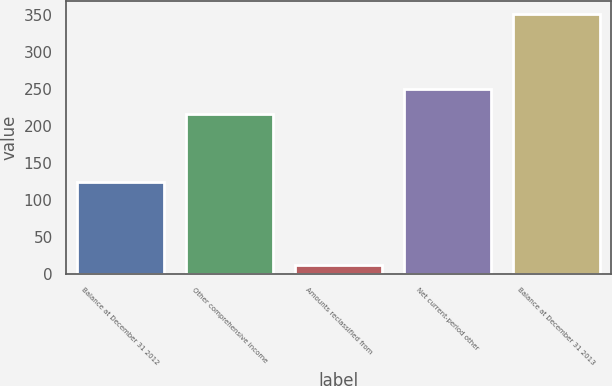<chart> <loc_0><loc_0><loc_500><loc_500><bar_chart><fcel>Balance at December 31 2012<fcel>Other comprehensive income<fcel>Amounts reclassified from<fcel>Net current-period other<fcel>Balance at December 31 2013<nl><fcel>124<fcel>216<fcel>12<fcel>250<fcel>352<nl></chart> 